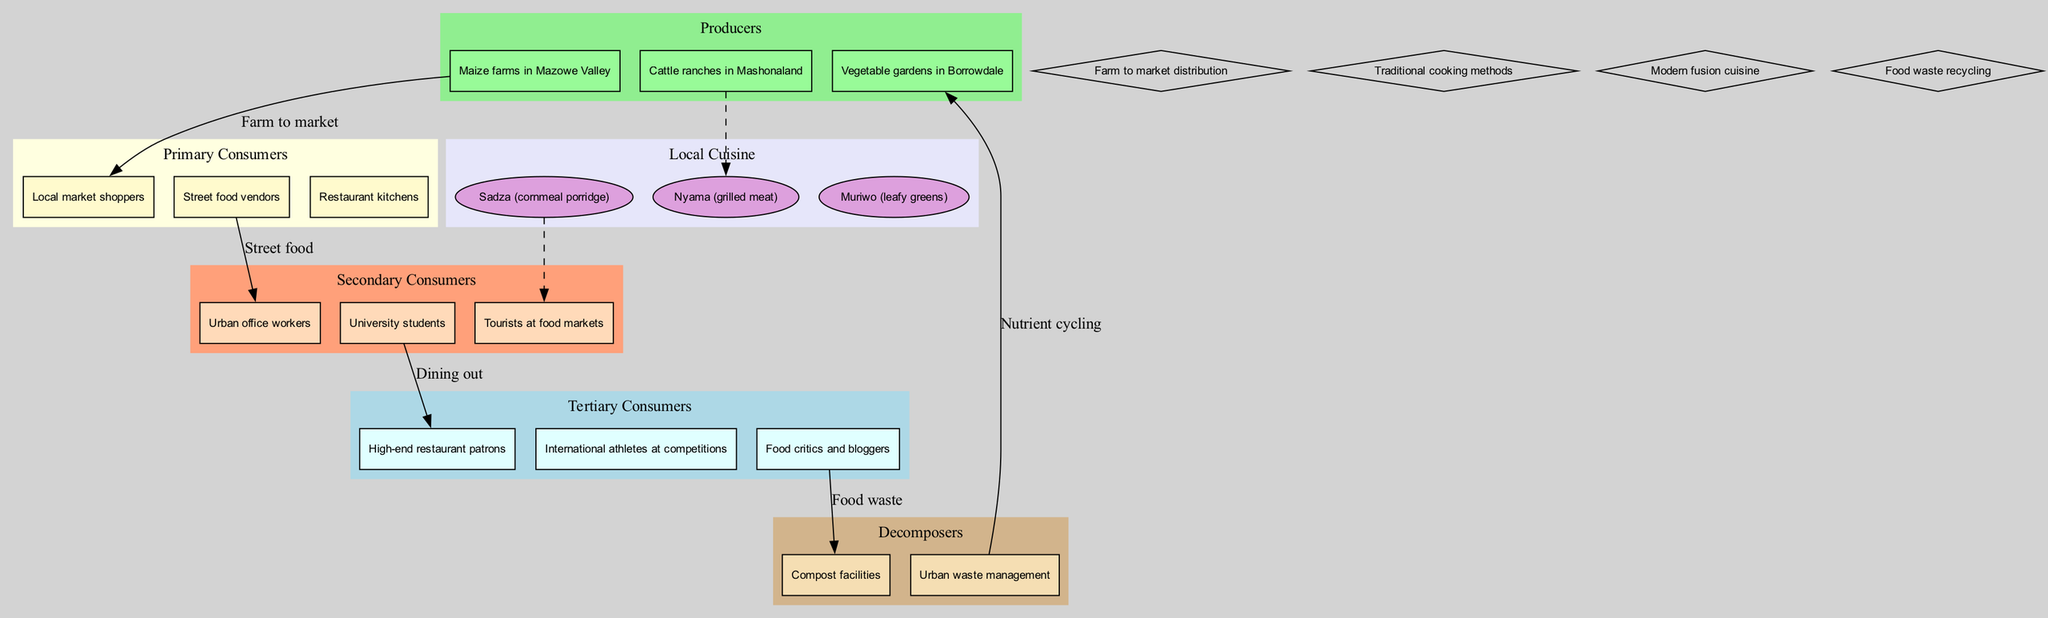What are the producers listed in the diagram? The producers are specifically identified in the "Producers" section of the diagram, which includes three distinct items: "Maize farms in Mazowe Valley," "Vegetable gardens in Borrowdale," and "Cattle ranches in Mashonaland."
Answer: Maize farms in Mazowe Valley, Vegetable gardens in Borrowdale, Cattle ranches in Mashonaland How many types of primary consumers are identified? By counting the specific nodes under the "Primary Consumers" category, there are three distinct types mentioned: "Local market shoppers," "Street food vendors," and "Restaurant kitchens."
Answer: 3 What is the food waste recycling process associated with in the diagram? The edge connecting "Food critics and bloggers" to "Compost facilities" indicates that food waste is recycled through compost, which suggests that the activities of food critics and bloggers potentially lead to food waste.
Answer: Compost facilities Which local cuisine is connected to urban office workers in the diagram? The edge connecting "Muriwo (leafy greens)" to "Urban office workers" indicates that this specific dish is served or consumed by urban office workers, highlighting a direct connection.
Answer: Muriwo (leafy greens) What role does the street food vendor play in the diagram? The edge from "Street food vendors" to "Urban office workers" signifies that street food vendors serve as a vital link, providing food to urban office workers, thus illustrating their importance in the local food chain.
Answer: Provides food to urban office workers How do high-end restaurant patrons interact with the local cuisine? The diagram shows a connection from "High-end restaurant patrons" to the local cuisine items, specifically indicating preferences or offerings available in high-end restaurants, denoting their interaction.
Answer: They consume local cuisine items Which consumer group is shown as having a direct relationship with compost facilities? The connection from "Food critics and bloggers" to "Compost facilities" highlights that food critics and bloggers have a direct relationship to compost facilities through their role in food reviews and waste management.
Answer: Food critics and bloggers 